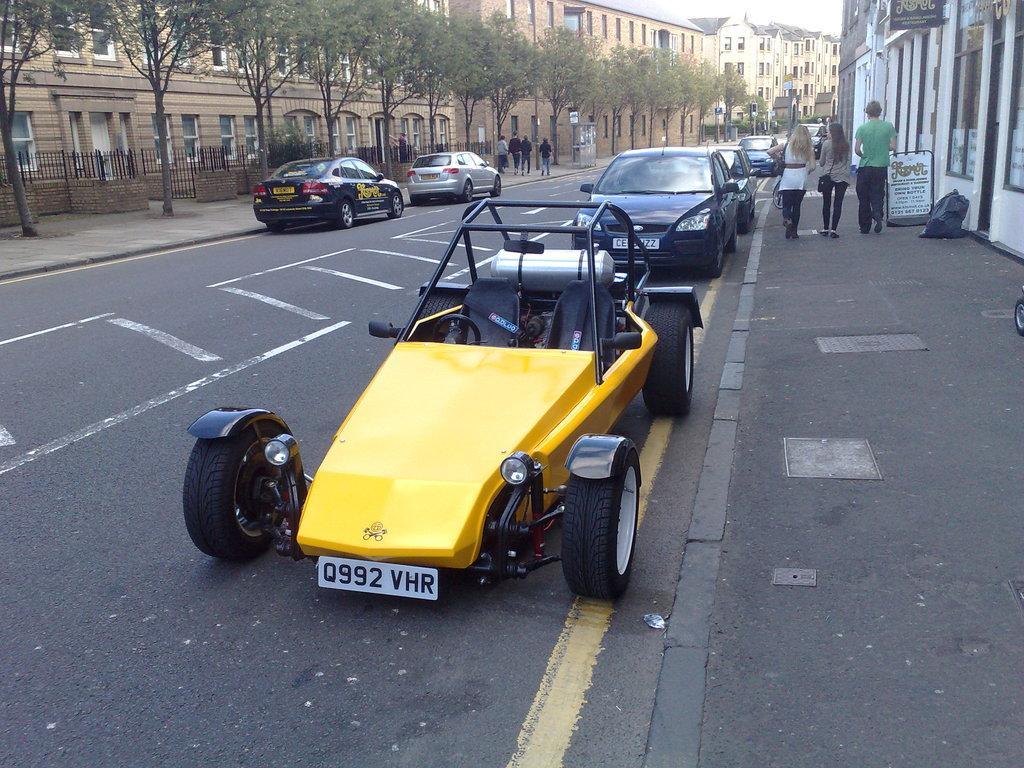In one or two sentences, can you explain what this image depicts? This image is clicked outside. There are buildings at the top. There are trees at the top. There are so many cars in the middle. There are some persons on the right side. 